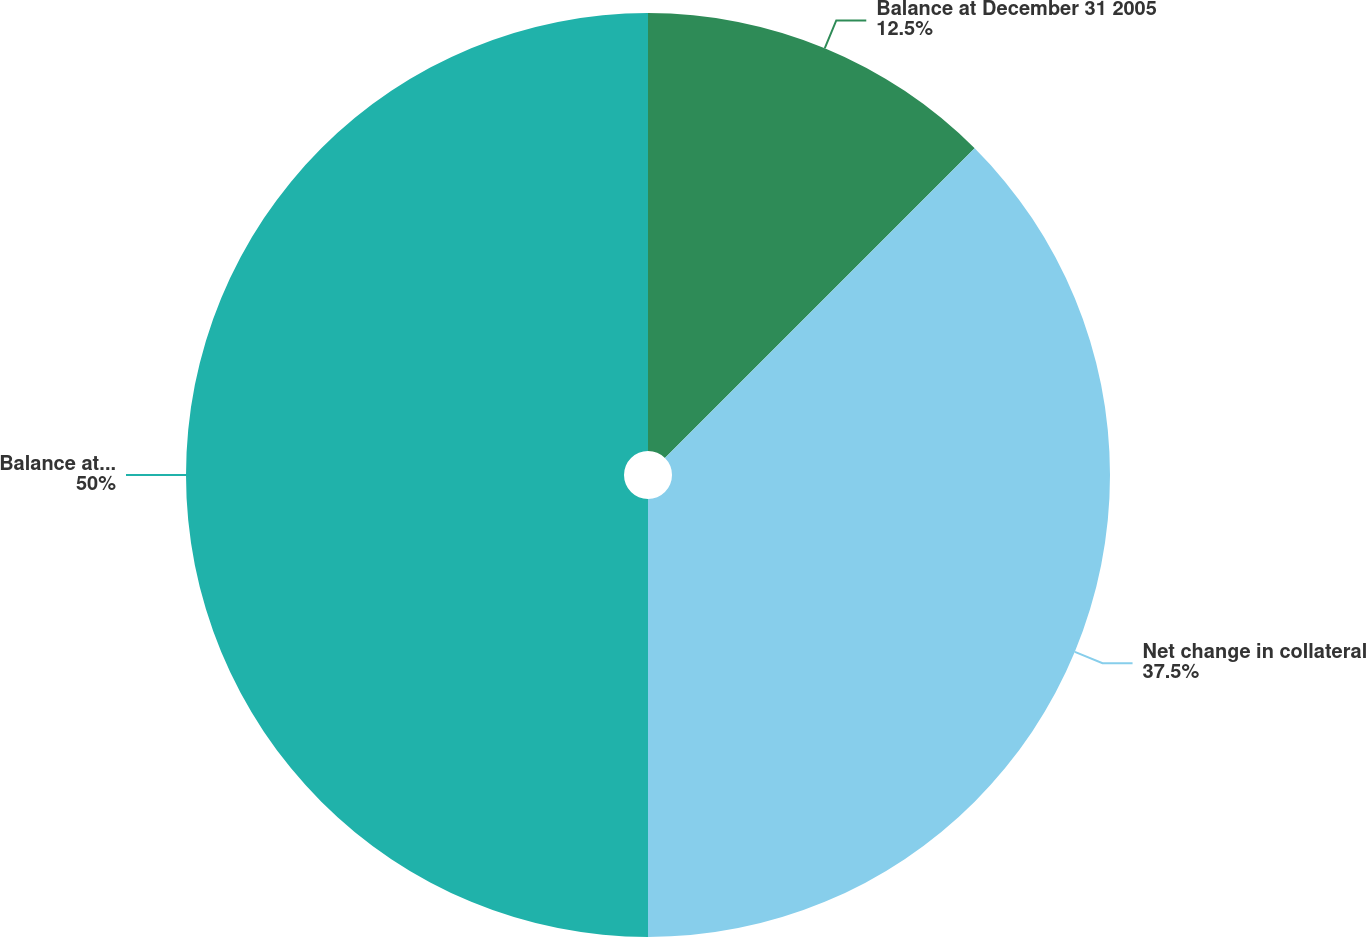<chart> <loc_0><loc_0><loc_500><loc_500><pie_chart><fcel>Balance at December 31 2005<fcel>Net change in collateral<fcel>Balance at December 31 2006<nl><fcel>12.5%<fcel>37.5%<fcel>50.0%<nl></chart> 